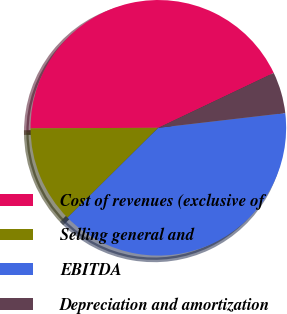Convert chart. <chart><loc_0><loc_0><loc_500><loc_500><pie_chart><fcel>Cost of revenues (exclusive of<fcel>Selling general and<fcel>EBITDA<fcel>Depreciation and amortization<nl><fcel>43.0%<fcel>12.35%<fcel>39.43%<fcel>5.22%<nl></chart> 